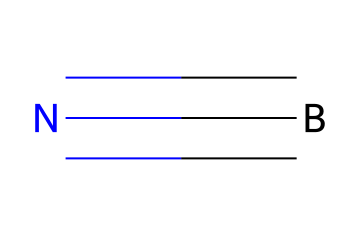What is the name of the compound represented by the SMILES? The compound is boron nitride, as indicated by the chemical structure denoted in the SMILES representation which contains one boron atom connected to one nitrogen atom by a triple bond.
Answer: boron nitride How many atoms are present in this chemical? In the SMILES representation, each element is counted: one boron atom and one nitrogen atom make a total of two atoms.
Answer: 2 What type of bond is present between boron and nitrogen? The bond between boron and nitrogen in boron nitride is identified as a triple bond, as denoted by the '#' symbol in the SMILES, which indicates the strength and type of chemical bond.
Answer: triple bond What is a key property of boron nitride relevant for VR hardware? Boron nitride is known for its excellent thermal conductivity, making it an effective heat-dissipating material for electronics, including VR hardware.
Answer: thermal conductivity Why is boron nitride suitable for heat-dissipating materials in VR hardware? Boron nitride's unique structure, comprising a stable arrangement of boron and nitrogen atoms, allows for efficient heat transfer, which is essential in managing the heat generated within VR devices.
Answer: efficient heat transfer What crystal structure can boron nitride form? Boron nitride can form a hexagonal structure similar to graphite, which contributes to its desirable properties in ceramics used for thermal management.
Answer: hexagonal structure What is the significance of the boron-nitrogen bond in ceramics? The strong boron-nitrogen bond imparts mechanical stability and contributes to the chemical resistance of ceramics, making them durable and effective as heat-dissipating materials.
Answer: mechanical stability 